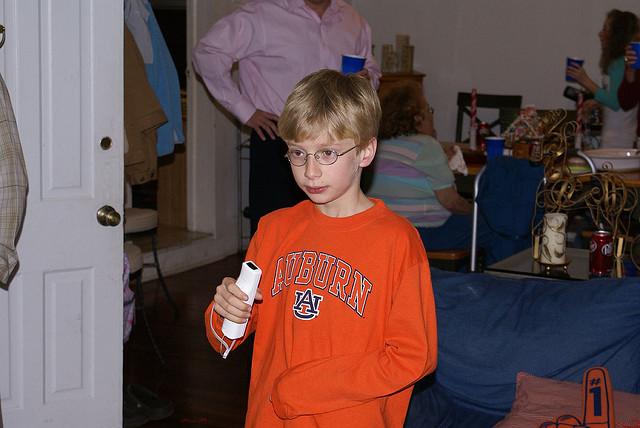What state is on the mans sweater?
Keep it brief. Alabama. What does the shirt say?
Concise answer only. Auburn. What color is this nerd boys shirt?
Keep it brief. Orange. What does the boy have on his face?
Be succinct. Glasses. 